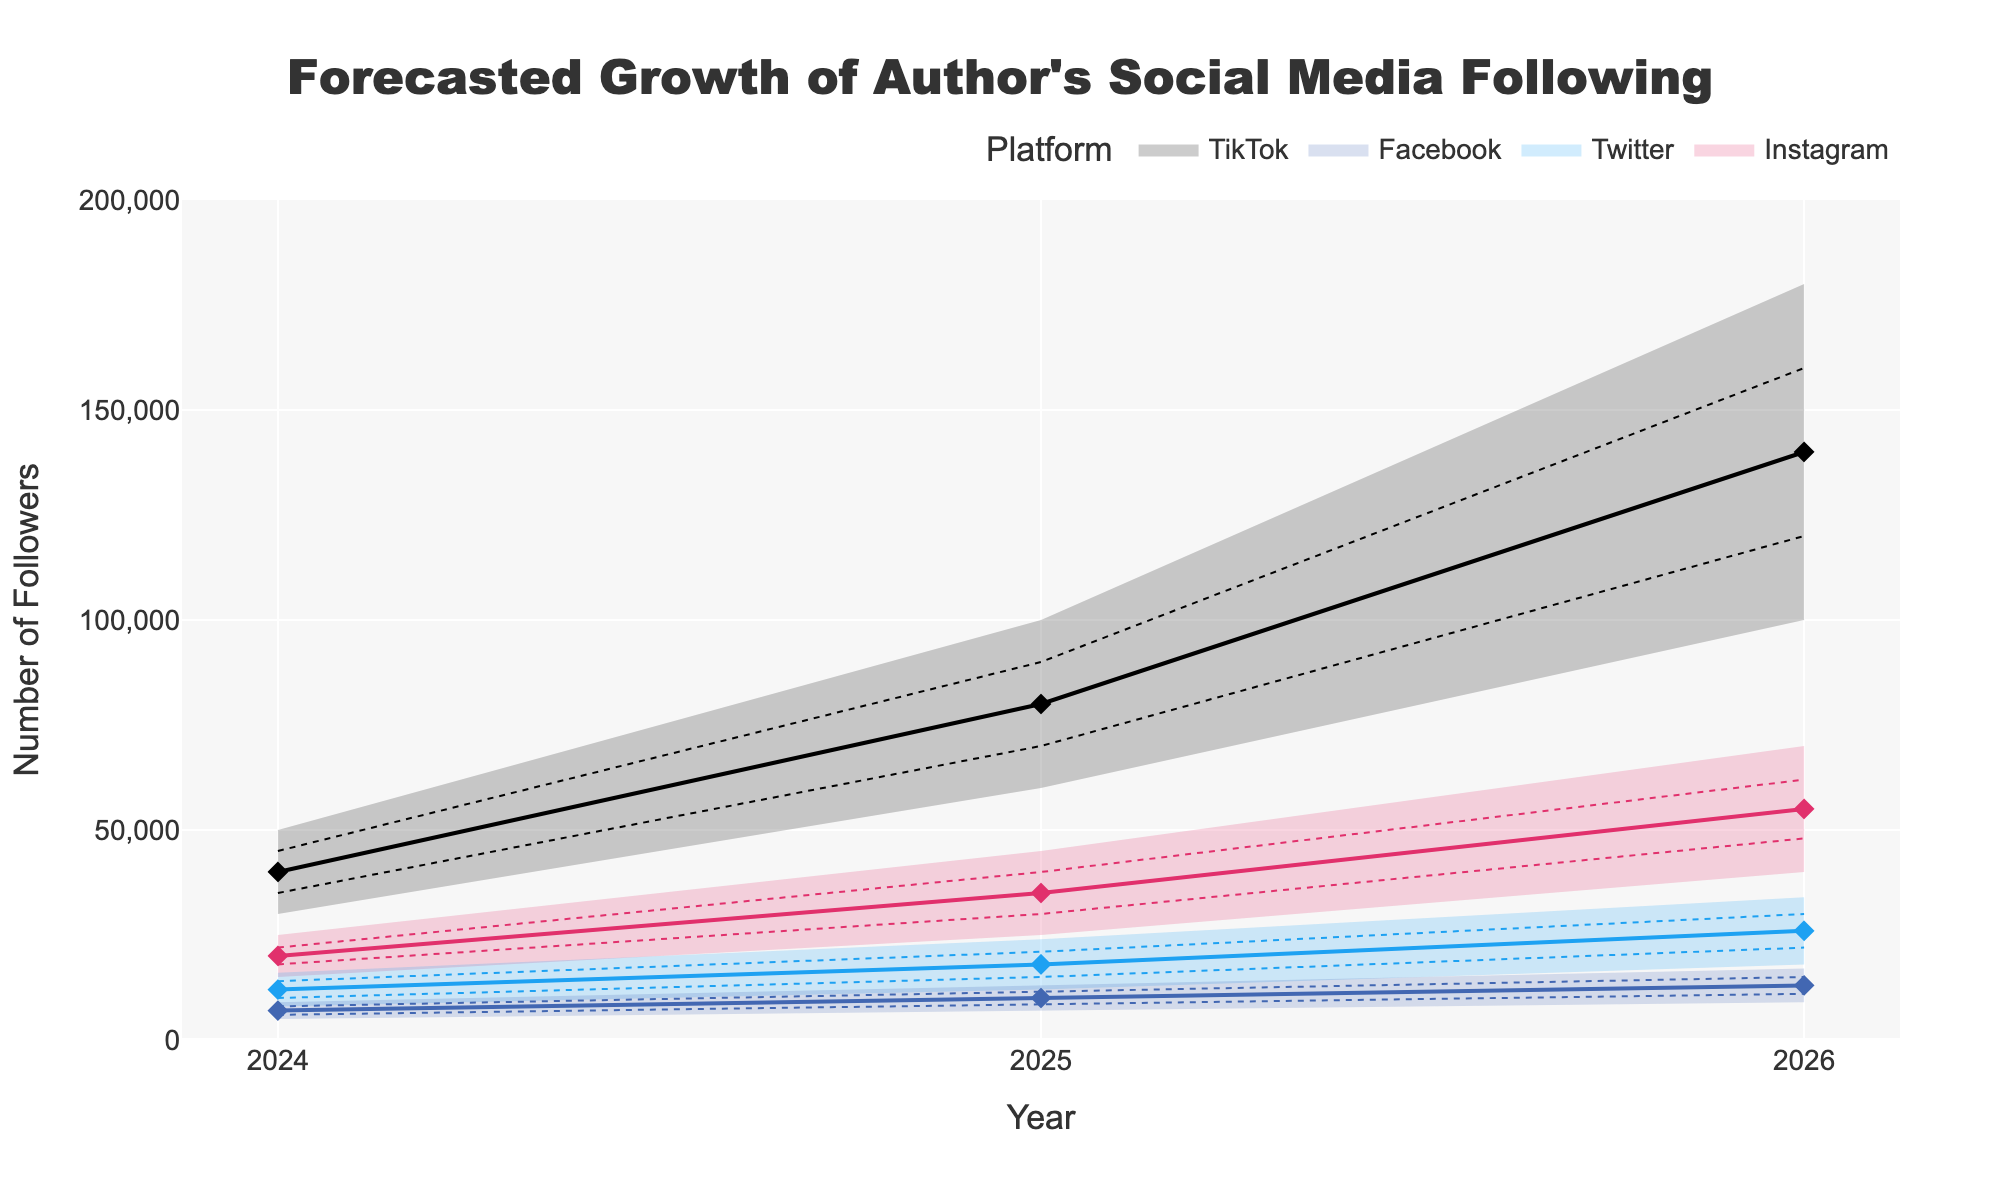How many social media platforms are represented in the forecast? The plot includes different-colored lines for each platform. We can count the number of unique lines or color legends to determine the number of platforms.
Answer: 4 Which platform is forecasted to have the highest median number of followers in 2026? By inspecting the median value (marked with diamonds) for each platform in the year 2026, the platform with the highest median is identified.
Answer: TikTok What is the range of projected followers for Instagram in 2025? For Instagram in 2025, the range is between the lower bound and the upper bound values. These values are given explicitly in the plot.
Answer: 25000-45000 How does the median number of Twitter followers in 2025 compare to the median number in 2026? The median values for Twitter in 2025 and 2026 are shown as diamond markers. We can compare these two values directly.
Answer: 18000 vs. 26000 By how much is TikTok's median forecasted followers in 2026 expected to increase from 2025? Identify the median values for TikTok in 2025 and 2026 and calculate the difference between them.
Answer: 60000 Which platform shows the widest range in 2024, and what is that range? Compare the ranges (upper minus lower) for all platforms in 2024 to identify the one with the widest range.
Answer: TikTok, 20000 What is the projected median number of Facebook followers in 2025 compared to Instagram in the same year? Check the diamond marker for the median number of followers for both Facebook and Instagram in 2025 and compare the values.
Answer: Facebook: 10000; Instagram: 35000 Which platform has the most conservative (narrowest) forecast range in 2026? Compare the forecast ranges of all platforms in 2026 and find the one with the smallest difference between the upper and lower bounds.
Answer: Facebook What visual element is used to indicate the median forecast value for each platform? Identify the visual marker or style in the plot that represents the median forecast value.
Answer: Diamond markers 